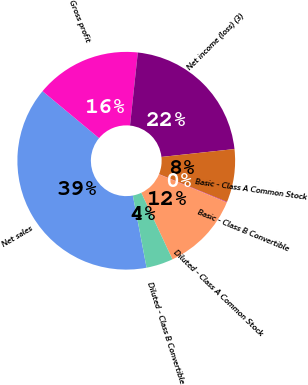<chart> <loc_0><loc_0><loc_500><loc_500><pie_chart><fcel>Net sales<fcel>Gross profit<fcel>Net income (loss) (3)<fcel>Basic - Class A Common Stock<fcel>Basic - Class B Convertible<fcel>Diluted - Class A Common Stock<fcel>Diluted - Class B Convertible<nl><fcel>39.02%<fcel>15.66%<fcel>21.59%<fcel>7.88%<fcel>0.09%<fcel>11.77%<fcel>3.98%<nl></chart> 